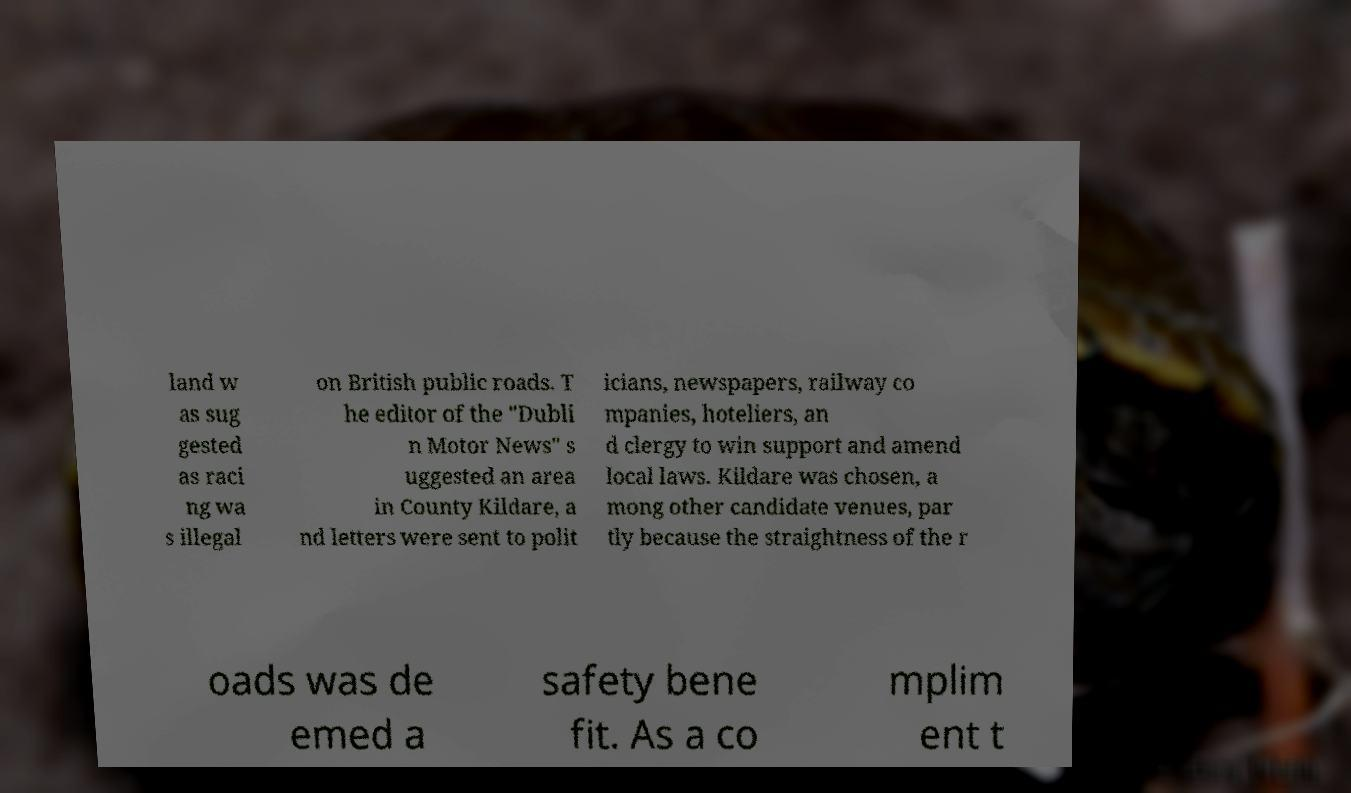Could you assist in decoding the text presented in this image and type it out clearly? land w as sug gested as raci ng wa s illegal on British public roads. T he editor of the "Dubli n Motor News" s uggested an area in County Kildare, a nd letters were sent to polit icians, newspapers, railway co mpanies, hoteliers, an d clergy to win support and amend local laws. Kildare was chosen, a mong other candidate venues, par tly because the straightness of the r oads was de emed a safety bene fit. As a co mplim ent t 